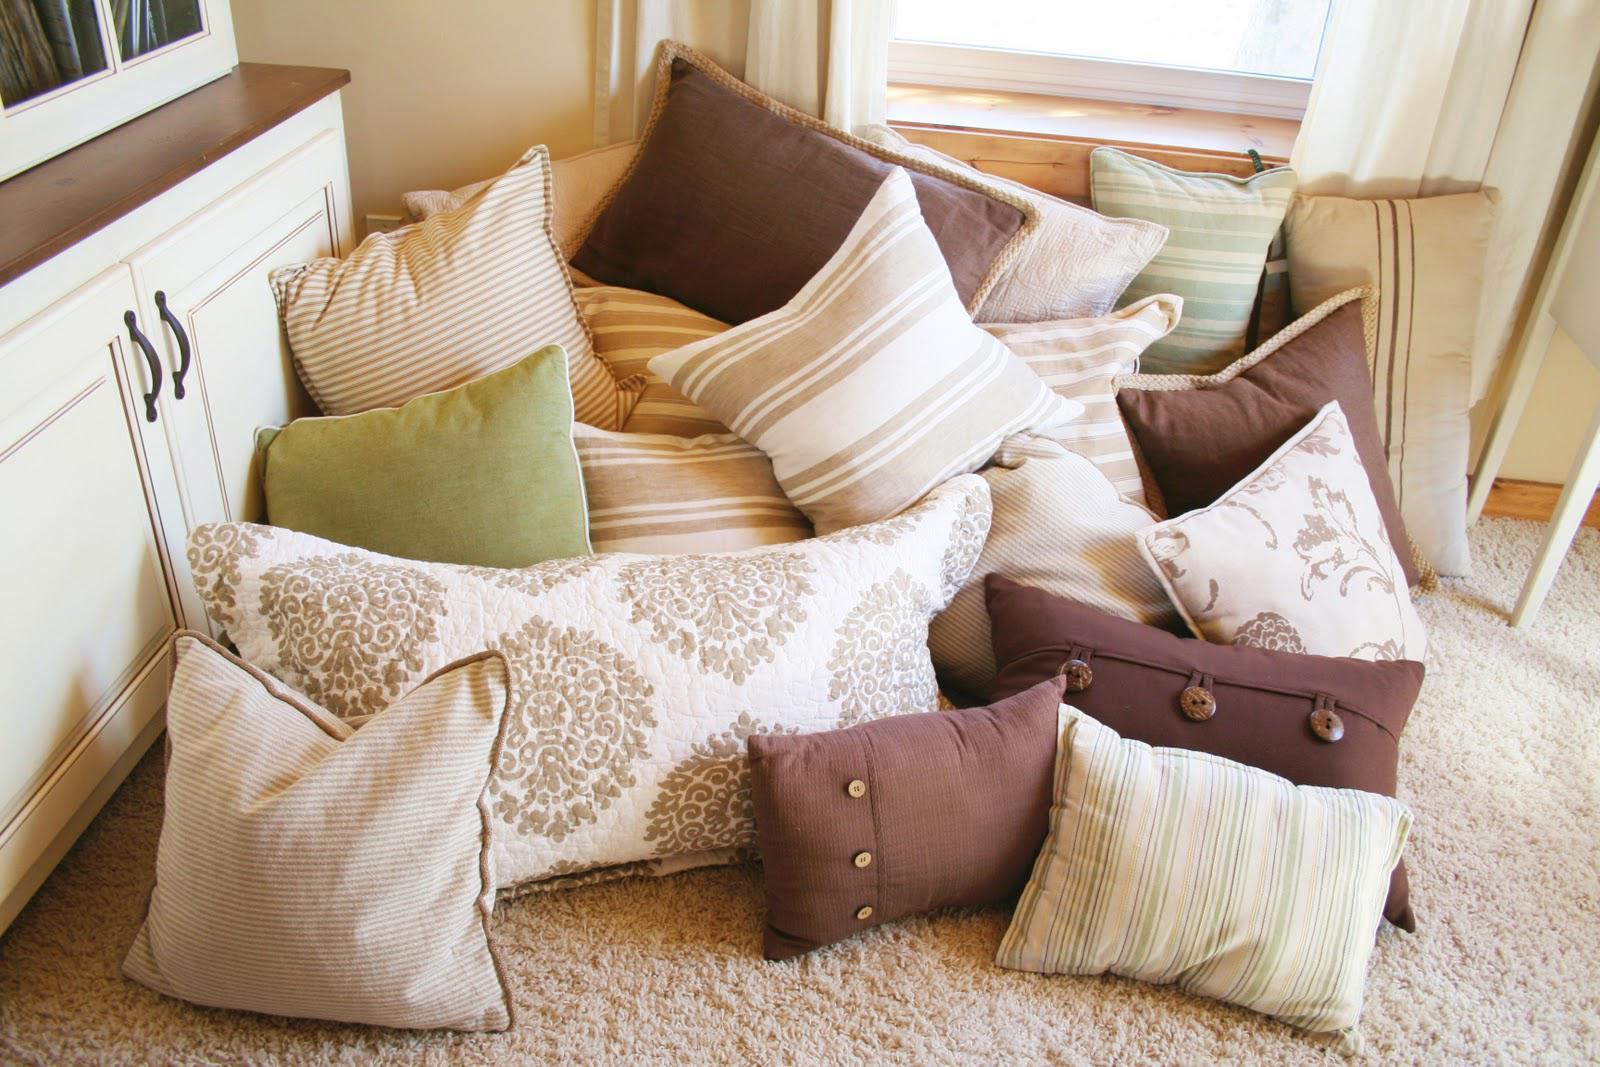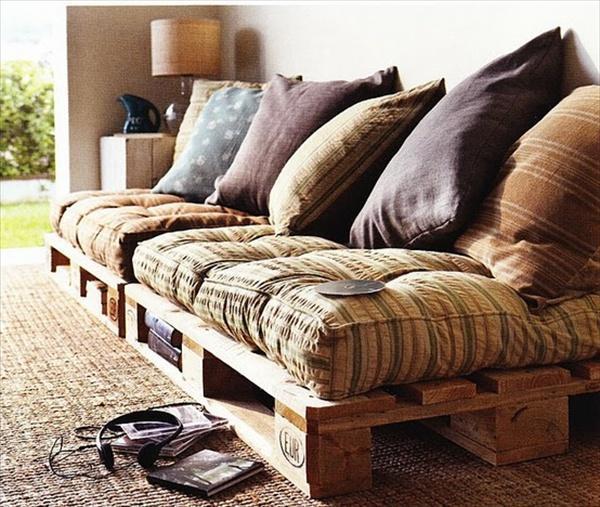The first image is the image on the left, the second image is the image on the right. Analyze the images presented: Is the assertion "An image shows a room featuring bright yellowish furniture." valid? Answer yes or no. No. 